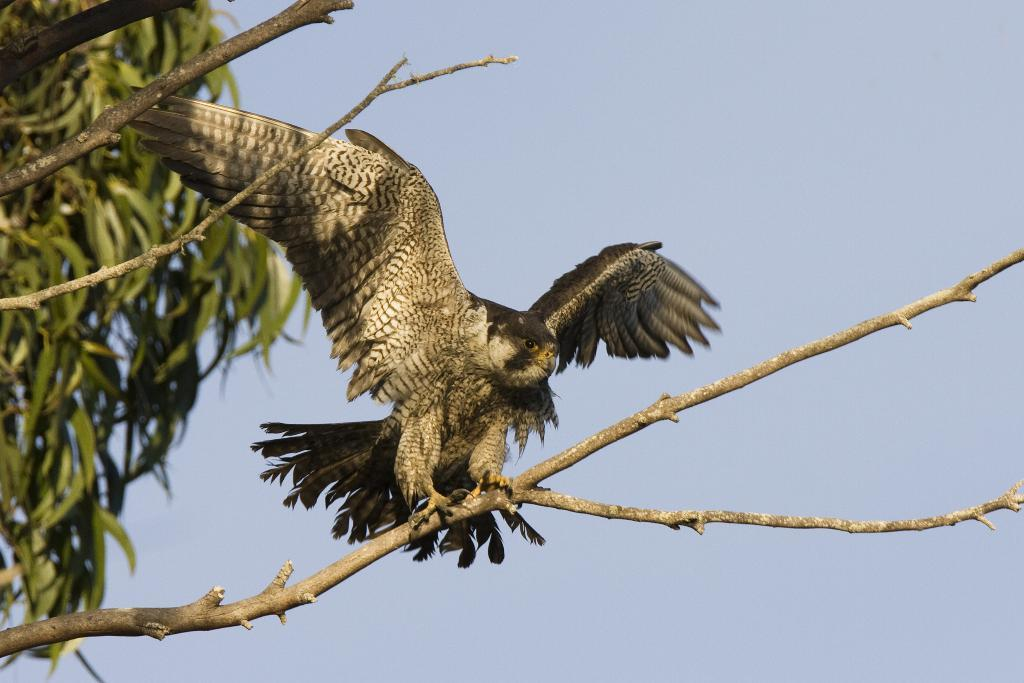What animal is the main subject of the image? There is an eagle in the image. Where is the eagle located in the image? The eagle is sitting on a stem. What can be seen on the left side of the image? There is a tree on the left side of the image. What is visible at the top of the image? The sky is visible at the top of the image. What type of jeans is the eagle wearing in the image? There is no mention of jeans or any clothing in the image; the eagle is a bird and does not wear clothing. What news headline can be seen on the tree in the image? There is no news or headline present in the image; it features an eagle sitting on a stem and a tree on the left side. 